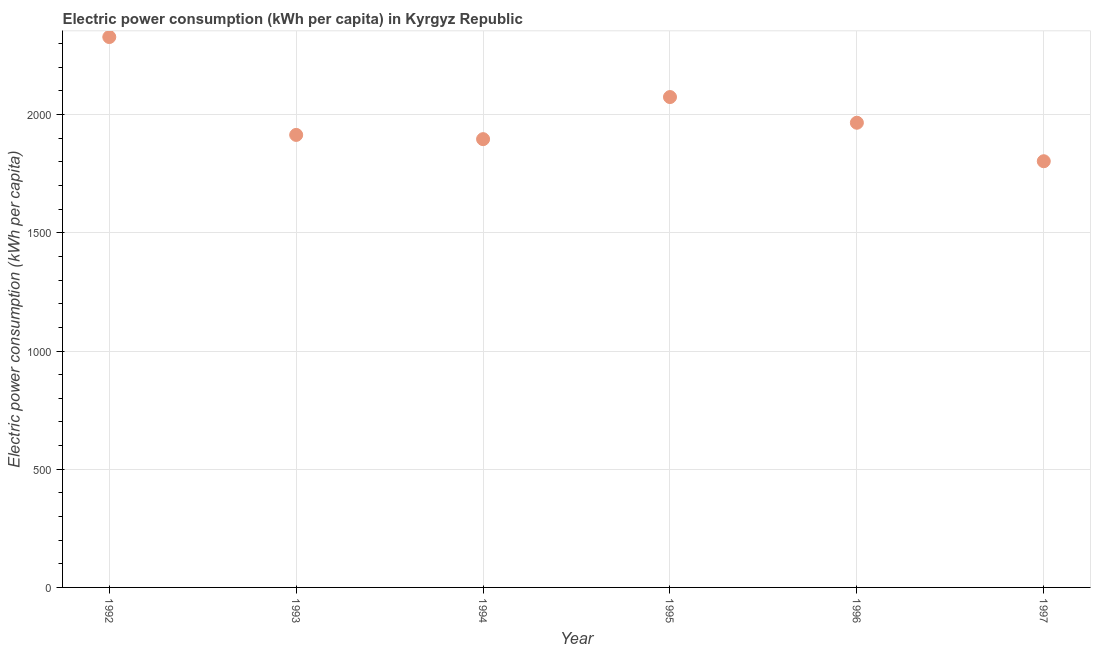What is the electric power consumption in 1996?
Your answer should be compact. 1965.69. Across all years, what is the maximum electric power consumption?
Your answer should be compact. 2328.25. Across all years, what is the minimum electric power consumption?
Provide a succinct answer. 1802.87. What is the sum of the electric power consumption?
Keep it short and to the point. 1.20e+04. What is the difference between the electric power consumption in 1993 and 1997?
Provide a succinct answer. 111.36. What is the average electric power consumption per year?
Your answer should be compact. 1996.95. What is the median electric power consumption?
Your answer should be very brief. 1939.96. Do a majority of the years between 1997 and 1996 (inclusive) have electric power consumption greater than 400 kWh per capita?
Your response must be concise. No. What is the ratio of the electric power consumption in 1993 to that in 1997?
Provide a succinct answer. 1.06. Is the difference between the electric power consumption in 1993 and 1995 greater than the difference between any two years?
Your answer should be compact. No. What is the difference between the highest and the second highest electric power consumption?
Your answer should be compact. 253.87. What is the difference between the highest and the lowest electric power consumption?
Provide a succinct answer. 525.38. In how many years, is the electric power consumption greater than the average electric power consumption taken over all years?
Provide a succinct answer. 2. Are the values on the major ticks of Y-axis written in scientific E-notation?
Provide a short and direct response. No. Does the graph contain any zero values?
Keep it short and to the point. No. What is the title of the graph?
Ensure brevity in your answer.  Electric power consumption (kWh per capita) in Kyrgyz Republic. What is the label or title of the Y-axis?
Offer a terse response. Electric power consumption (kWh per capita). What is the Electric power consumption (kWh per capita) in 1992?
Your answer should be very brief. 2328.25. What is the Electric power consumption (kWh per capita) in 1993?
Ensure brevity in your answer.  1914.23. What is the Electric power consumption (kWh per capita) in 1994?
Your answer should be very brief. 1896.3. What is the Electric power consumption (kWh per capita) in 1995?
Offer a terse response. 2074.38. What is the Electric power consumption (kWh per capita) in 1996?
Your answer should be very brief. 1965.69. What is the Electric power consumption (kWh per capita) in 1997?
Keep it short and to the point. 1802.87. What is the difference between the Electric power consumption (kWh per capita) in 1992 and 1993?
Offer a terse response. 414.02. What is the difference between the Electric power consumption (kWh per capita) in 1992 and 1994?
Your answer should be compact. 431.95. What is the difference between the Electric power consumption (kWh per capita) in 1992 and 1995?
Offer a very short reply. 253.87. What is the difference between the Electric power consumption (kWh per capita) in 1992 and 1996?
Keep it short and to the point. 362.56. What is the difference between the Electric power consumption (kWh per capita) in 1992 and 1997?
Your answer should be very brief. 525.38. What is the difference between the Electric power consumption (kWh per capita) in 1993 and 1994?
Offer a terse response. 17.93. What is the difference between the Electric power consumption (kWh per capita) in 1993 and 1995?
Offer a very short reply. -160.15. What is the difference between the Electric power consumption (kWh per capita) in 1993 and 1996?
Your answer should be very brief. -51.46. What is the difference between the Electric power consumption (kWh per capita) in 1993 and 1997?
Offer a very short reply. 111.36. What is the difference between the Electric power consumption (kWh per capita) in 1994 and 1995?
Your response must be concise. -178.08. What is the difference between the Electric power consumption (kWh per capita) in 1994 and 1996?
Ensure brevity in your answer.  -69.39. What is the difference between the Electric power consumption (kWh per capita) in 1994 and 1997?
Your answer should be compact. 93.43. What is the difference between the Electric power consumption (kWh per capita) in 1995 and 1996?
Offer a very short reply. 108.69. What is the difference between the Electric power consumption (kWh per capita) in 1995 and 1997?
Offer a very short reply. 271.51. What is the difference between the Electric power consumption (kWh per capita) in 1996 and 1997?
Your response must be concise. 162.82. What is the ratio of the Electric power consumption (kWh per capita) in 1992 to that in 1993?
Provide a short and direct response. 1.22. What is the ratio of the Electric power consumption (kWh per capita) in 1992 to that in 1994?
Offer a very short reply. 1.23. What is the ratio of the Electric power consumption (kWh per capita) in 1992 to that in 1995?
Your response must be concise. 1.12. What is the ratio of the Electric power consumption (kWh per capita) in 1992 to that in 1996?
Provide a succinct answer. 1.18. What is the ratio of the Electric power consumption (kWh per capita) in 1992 to that in 1997?
Your answer should be very brief. 1.29. What is the ratio of the Electric power consumption (kWh per capita) in 1993 to that in 1994?
Offer a very short reply. 1.01. What is the ratio of the Electric power consumption (kWh per capita) in 1993 to that in 1995?
Make the answer very short. 0.92. What is the ratio of the Electric power consumption (kWh per capita) in 1993 to that in 1996?
Ensure brevity in your answer.  0.97. What is the ratio of the Electric power consumption (kWh per capita) in 1993 to that in 1997?
Provide a succinct answer. 1.06. What is the ratio of the Electric power consumption (kWh per capita) in 1994 to that in 1995?
Give a very brief answer. 0.91. What is the ratio of the Electric power consumption (kWh per capita) in 1994 to that in 1997?
Make the answer very short. 1.05. What is the ratio of the Electric power consumption (kWh per capita) in 1995 to that in 1996?
Give a very brief answer. 1.05. What is the ratio of the Electric power consumption (kWh per capita) in 1995 to that in 1997?
Make the answer very short. 1.15. What is the ratio of the Electric power consumption (kWh per capita) in 1996 to that in 1997?
Ensure brevity in your answer.  1.09. 